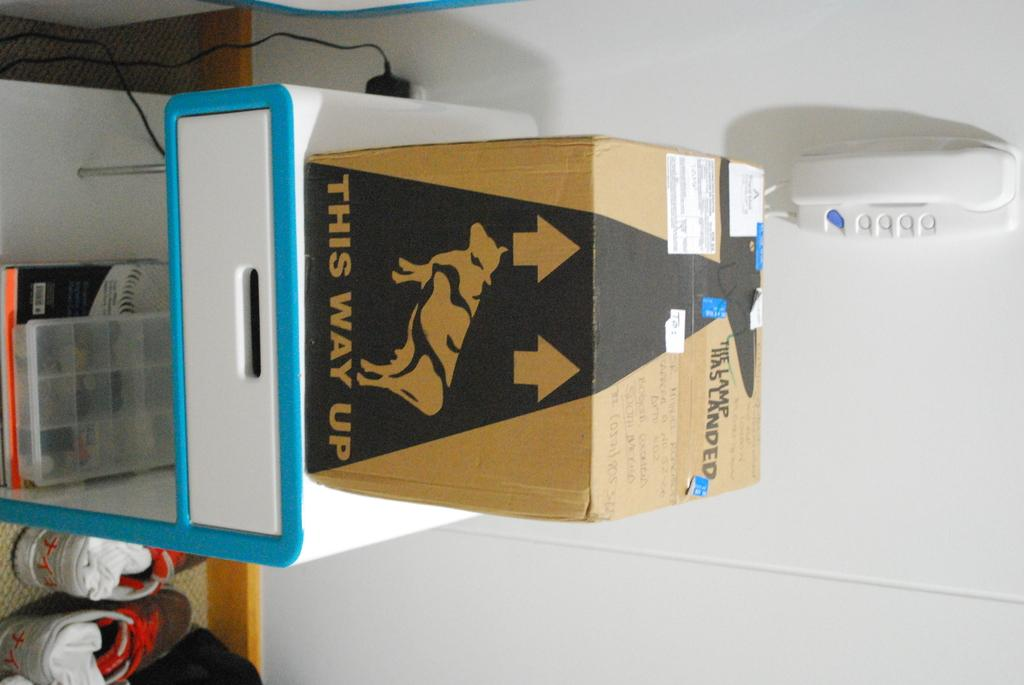<image>
Present a compact description of the photo's key features. A box with a this way up warning on the box. 